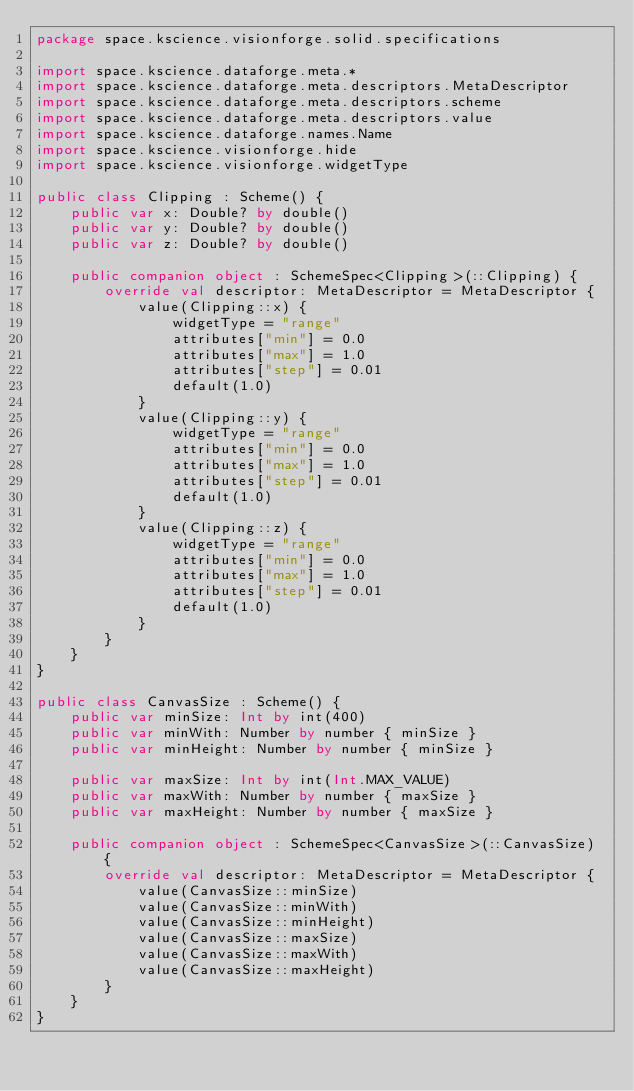<code> <loc_0><loc_0><loc_500><loc_500><_Kotlin_>package space.kscience.visionforge.solid.specifications

import space.kscience.dataforge.meta.*
import space.kscience.dataforge.meta.descriptors.MetaDescriptor
import space.kscience.dataforge.meta.descriptors.scheme
import space.kscience.dataforge.meta.descriptors.value
import space.kscience.dataforge.names.Name
import space.kscience.visionforge.hide
import space.kscience.visionforge.widgetType

public class Clipping : Scheme() {
    public var x: Double? by double()
    public var y: Double? by double()
    public var z: Double? by double()

    public companion object : SchemeSpec<Clipping>(::Clipping) {
        override val descriptor: MetaDescriptor = MetaDescriptor {
            value(Clipping::x) {
                widgetType = "range"
                attributes["min"] = 0.0
                attributes["max"] = 1.0
                attributes["step"] = 0.01
                default(1.0)
            }
            value(Clipping::y) {
                widgetType = "range"
                attributes["min"] = 0.0
                attributes["max"] = 1.0
                attributes["step"] = 0.01
                default(1.0)
            }
            value(Clipping::z) {
                widgetType = "range"
                attributes["min"] = 0.0
                attributes["max"] = 1.0
                attributes["step"] = 0.01
                default(1.0)
            }
        }
    }
}

public class CanvasSize : Scheme() {
    public var minSize: Int by int(400)
    public var minWith: Number by number { minSize }
    public var minHeight: Number by number { minSize }

    public var maxSize: Int by int(Int.MAX_VALUE)
    public var maxWith: Number by number { maxSize }
    public var maxHeight: Number by number { maxSize }

    public companion object : SchemeSpec<CanvasSize>(::CanvasSize) {
        override val descriptor: MetaDescriptor = MetaDescriptor {
            value(CanvasSize::minSize)
            value(CanvasSize::minWith)
            value(CanvasSize::minHeight)
            value(CanvasSize::maxSize)
            value(CanvasSize::maxWith)
            value(CanvasSize::maxHeight)
        }
    }
}
</code> 